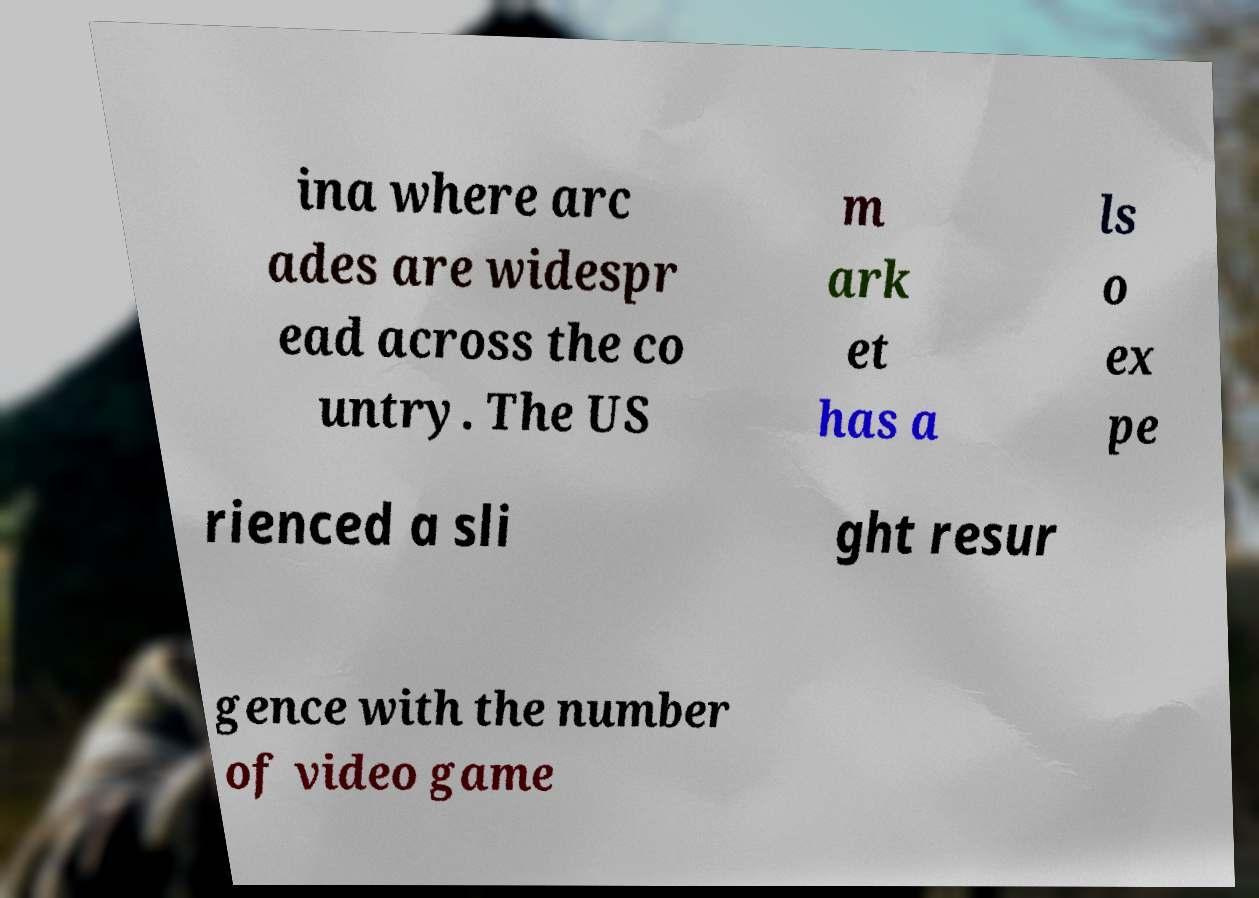Could you assist in decoding the text presented in this image and type it out clearly? ina where arc ades are widespr ead across the co untry. The US m ark et has a ls o ex pe rienced a sli ght resur gence with the number of video game 